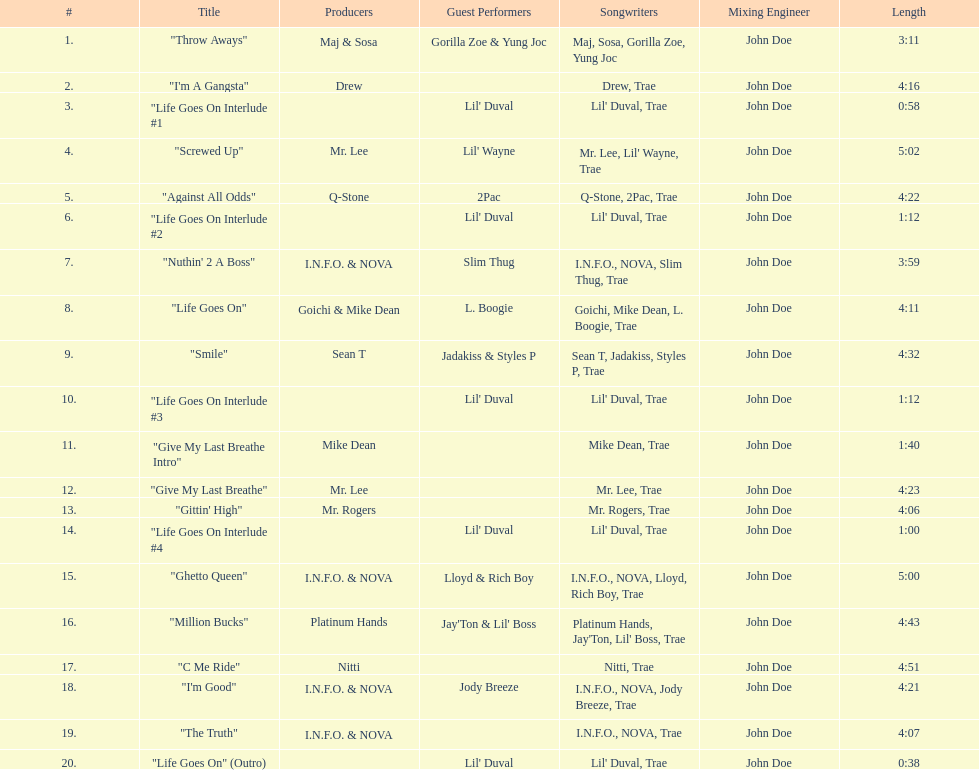What is the longest track on the album? "Screwed Up". 